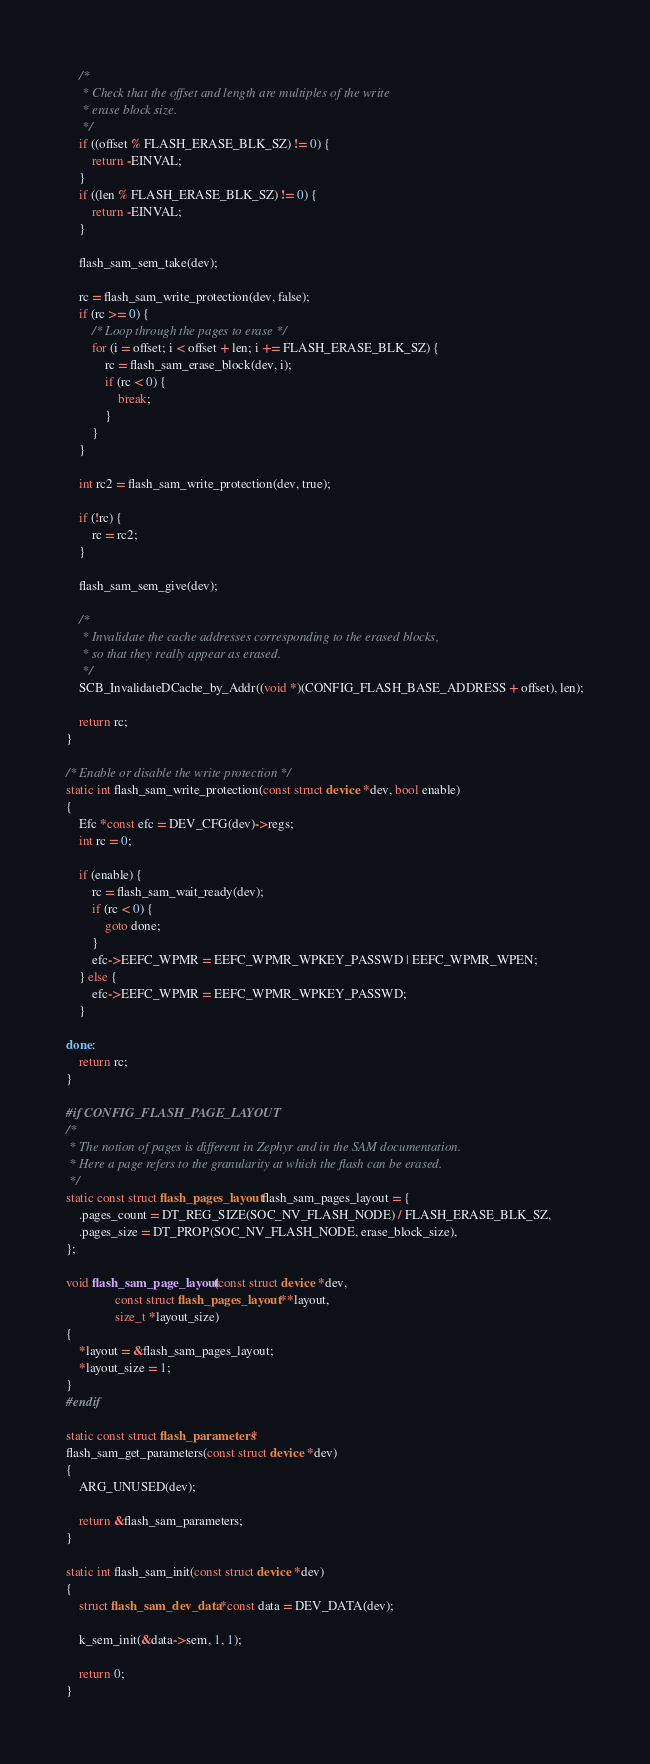Convert code to text. <code><loc_0><loc_0><loc_500><loc_500><_C_>
	/*
	 * Check that the offset and length are multiples of the write
	 * erase block size.
	 */
	if ((offset % FLASH_ERASE_BLK_SZ) != 0) {
		return -EINVAL;
	}
	if ((len % FLASH_ERASE_BLK_SZ) != 0) {
		return -EINVAL;
	}

	flash_sam_sem_take(dev);

	rc = flash_sam_write_protection(dev, false);
	if (rc >= 0) {
		/* Loop through the pages to erase */
		for (i = offset; i < offset + len; i += FLASH_ERASE_BLK_SZ) {
			rc = flash_sam_erase_block(dev, i);
			if (rc < 0) {
				break;
			}
		}
	}

	int rc2 = flash_sam_write_protection(dev, true);

	if (!rc) {
		rc = rc2;
	}

	flash_sam_sem_give(dev);

	/*
	 * Invalidate the cache addresses corresponding to the erased blocks,
	 * so that they really appear as erased.
	 */
	SCB_InvalidateDCache_by_Addr((void *)(CONFIG_FLASH_BASE_ADDRESS + offset), len);

	return rc;
}

/* Enable or disable the write protection */
static int flash_sam_write_protection(const struct device *dev, bool enable)
{
	Efc *const efc = DEV_CFG(dev)->regs;
	int rc = 0;

	if (enable) {
		rc = flash_sam_wait_ready(dev);
		if (rc < 0) {
			goto done;
		}
		efc->EEFC_WPMR = EEFC_WPMR_WPKEY_PASSWD | EEFC_WPMR_WPEN;
	} else {
		efc->EEFC_WPMR = EEFC_WPMR_WPKEY_PASSWD;
	}

done:
	return rc;
}

#if CONFIG_FLASH_PAGE_LAYOUT
/*
 * The notion of pages is different in Zephyr and in the SAM documentation.
 * Here a page refers to the granularity at which the flash can be erased.
 */
static const struct flash_pages_layout flash_sam_pages_layout = {
	.pages_count = DT_REG_SIZE(SOC_NV_FLASH_NODE) / FLASH_ERASE_BLK_SZ,
	.pages_size = DT_PROP(SOC_NV_FLASH_NODE, erase_block_size),
};

void flash_sam_page_layout(const struct device *dev,
			   const struct flash_pages_layout **layout,
			   size_t *layout_size)
{
	*layout = &flash_sam_pages_layout;
	*layout_size = 1;
}
#endif

static const struct flash_parameters *
flash_sam_get_parameters(const struct device *dev)
{
	ARG_UNUSED(dev);

	return &flash_sam_parameters;
}

static int flash_sam_init(const struct device *dev)
{
	struct flash_sam_dev_data *const data = DEV_DATA(dev);

	k_sem_init(&data->sem, 1, 1);

	return 0;
}
</code> 